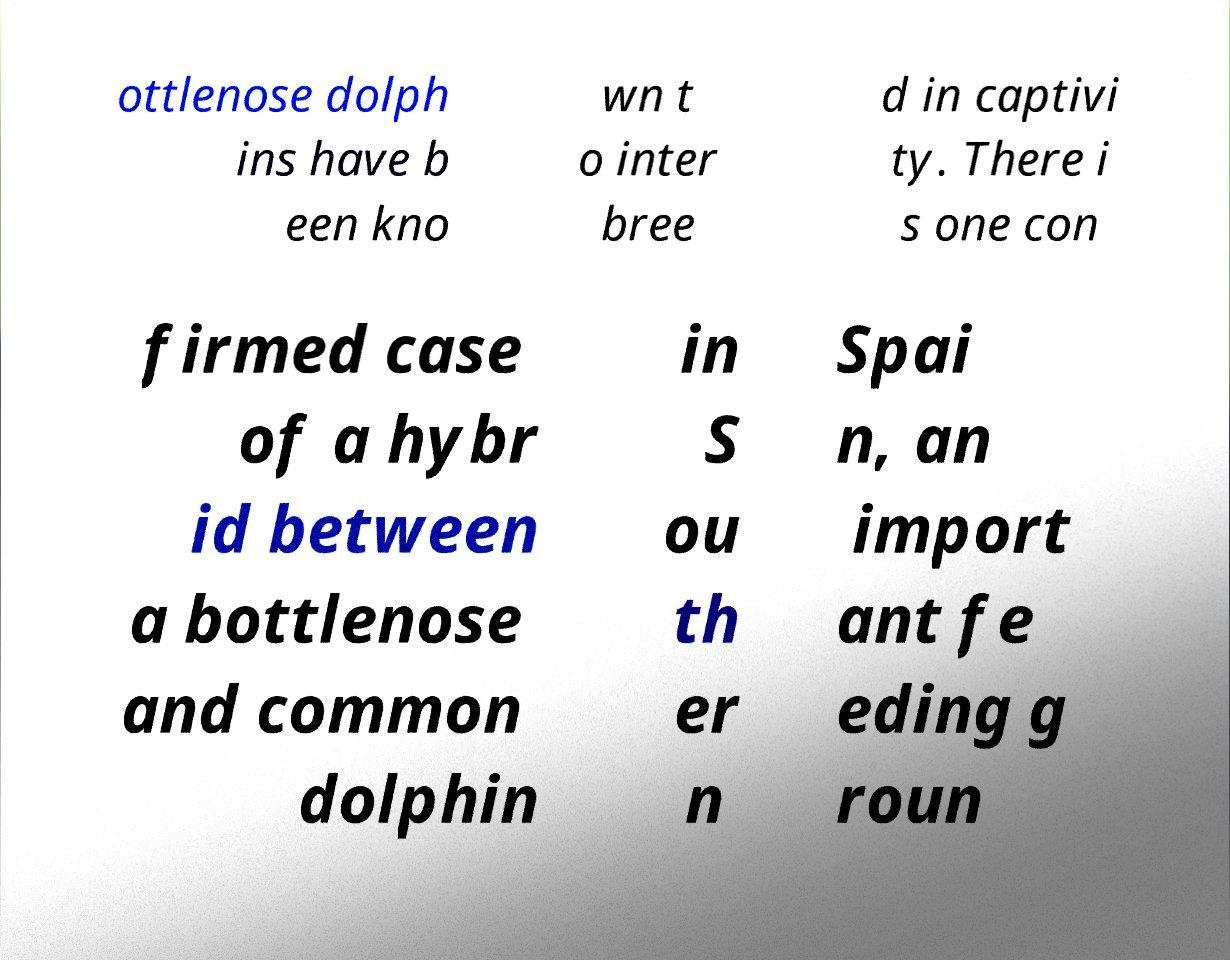Could you assist in decoding the text presented in this image and type it out clearly? ottlenose dolph ins have b een kno wn t o inter bree d in captivi ty. There i s one con firmed case of a hybr id between a bottlenose and common dolphin in S ou th er n Spai n, an import ant fe eding g roun 